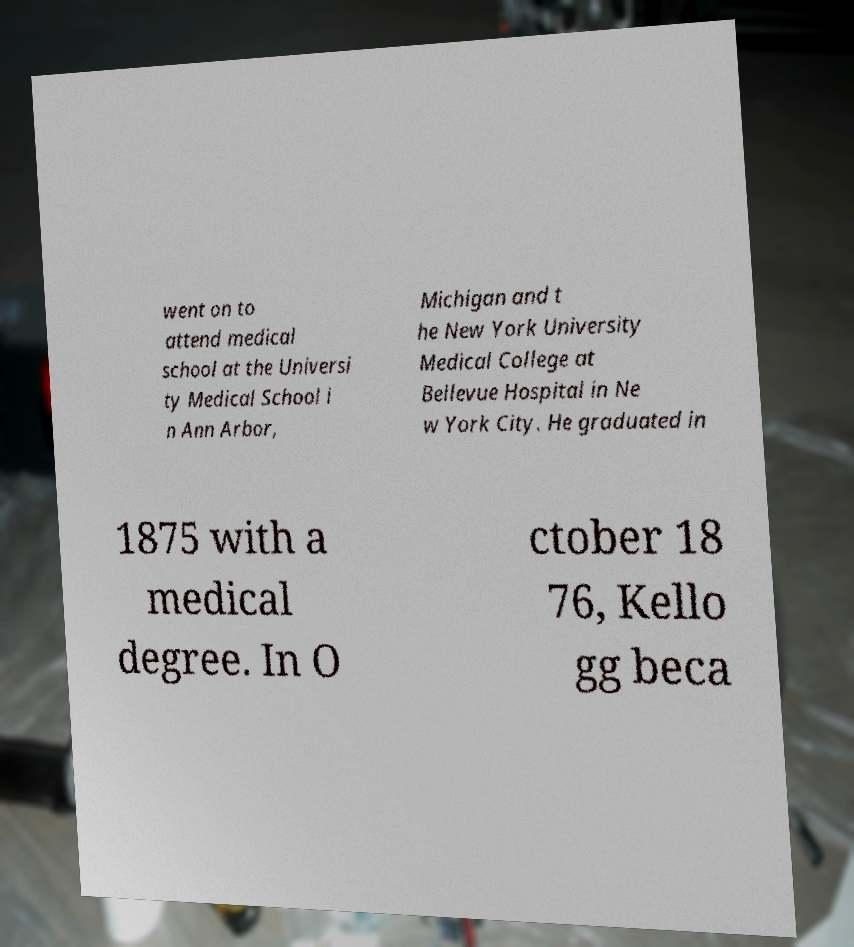Please identify and transcribe the text found in this image. went on to attend medical school at the Universi ty Medical School i n Ann Arbor, Michigan and t he New York University Medical College at Bellevue Hospital in Ne w York City. He graduated in 1875 with a medical degree. In O ctober 18 76, Kello gg beca 